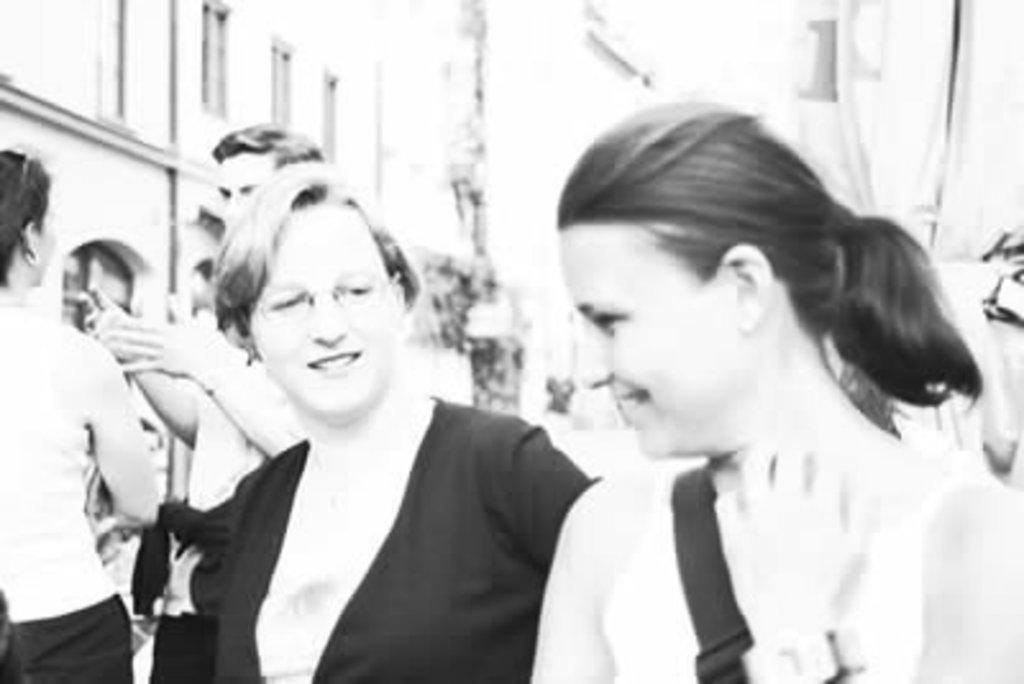What are the people in the image doing? The people in the image are standing in the center and smiling. What can be seen in the background of the image? There are buildings and poles visible in the background of the image. What type of prose is being recited by the horse in the image? There is no horse present in the image, and therefore no prose being recited. 